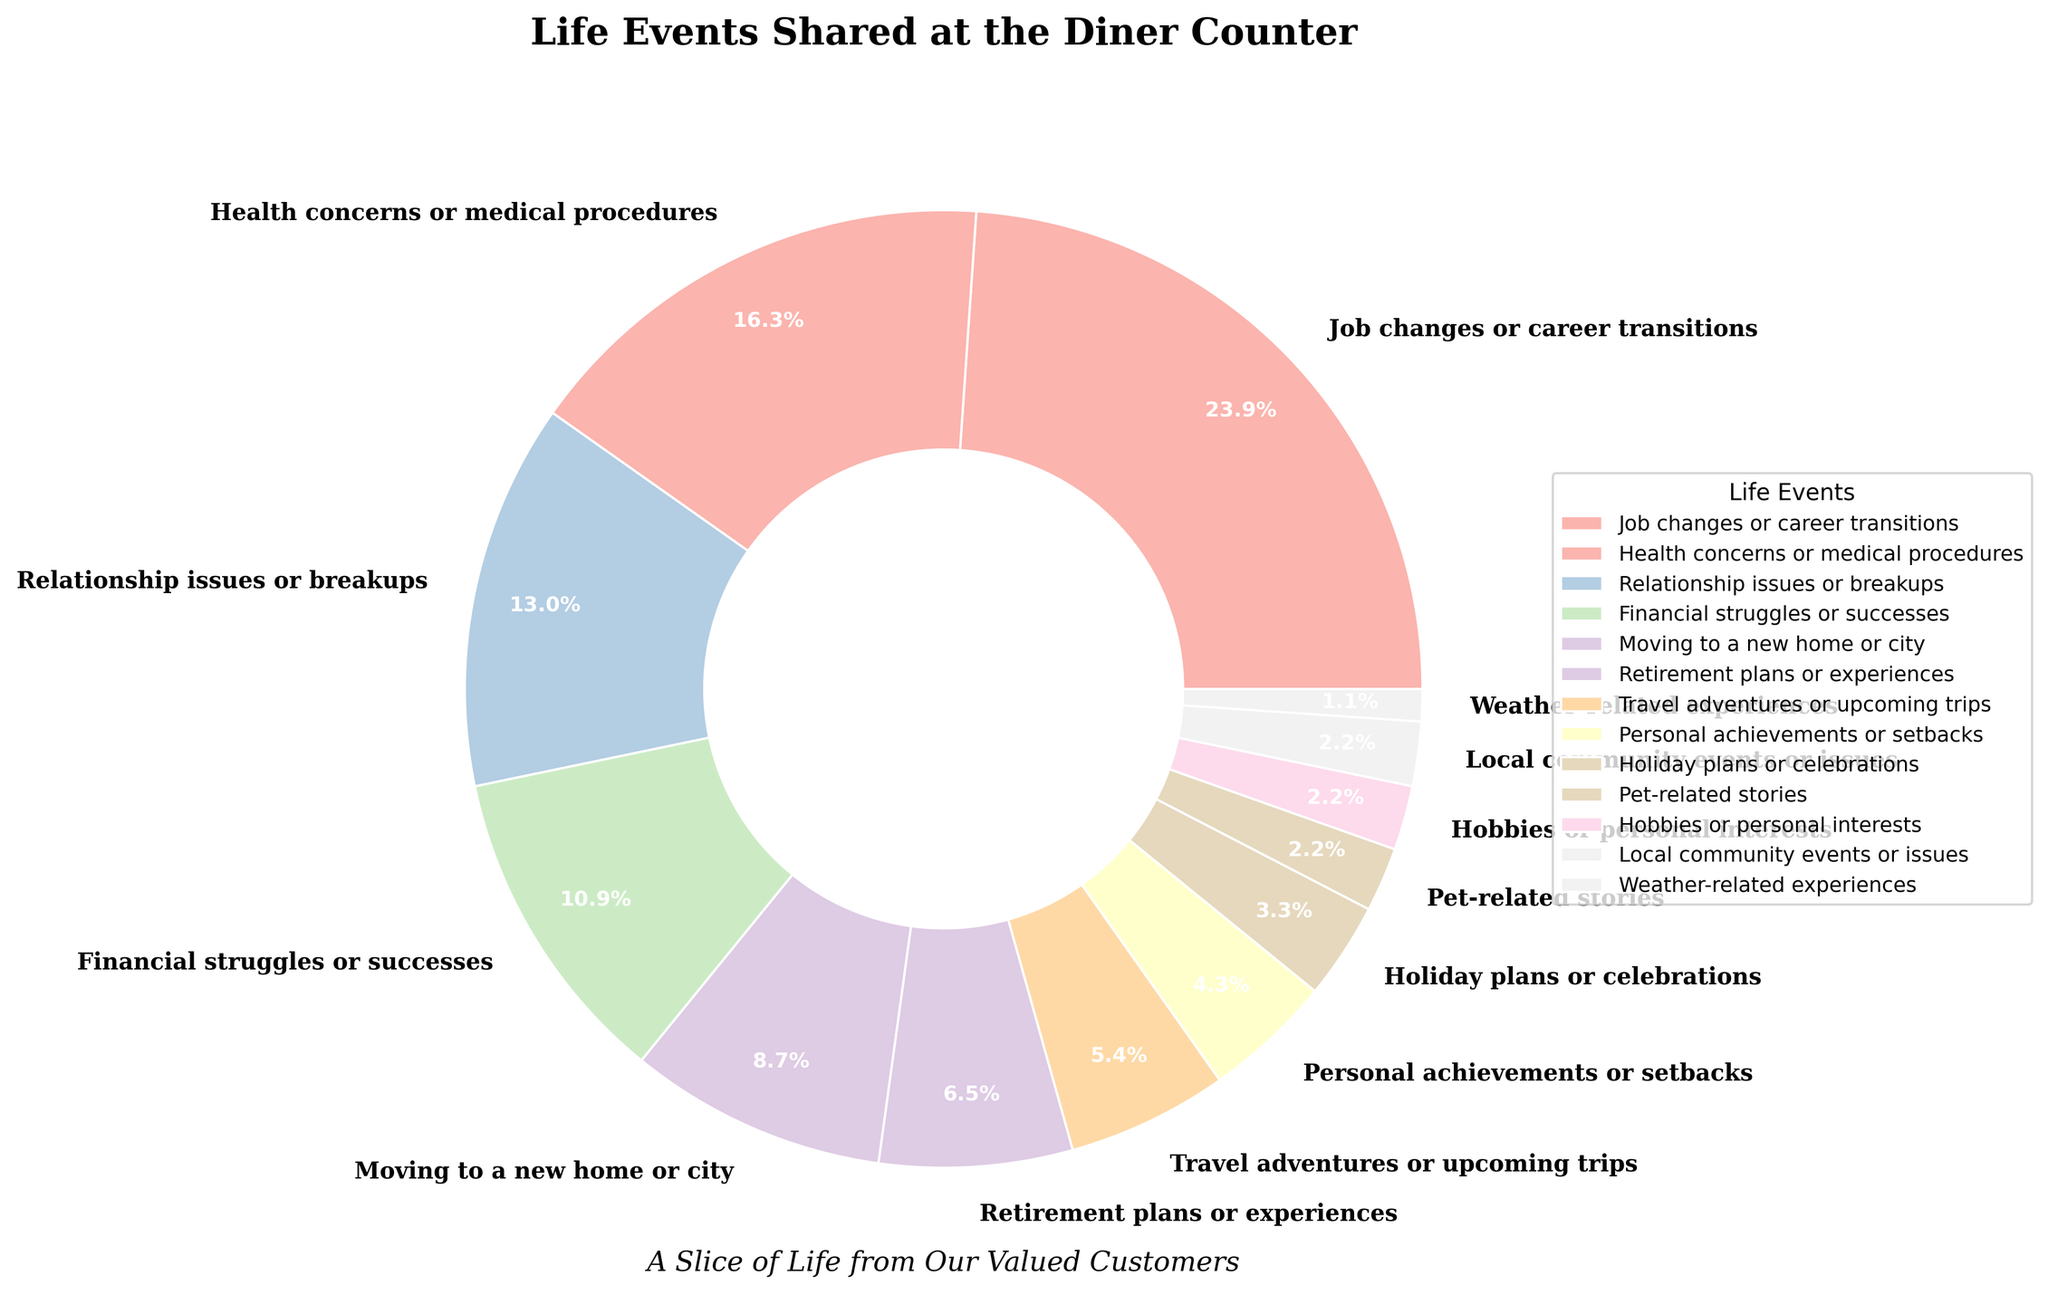Which life event is shared most frequently by customers? Refer to the largest slice in the pie chart and check its label. The largest slice is labeled "Job changes or career transitions" with a percentage of 22%.
Answer: Job changes or career transitions Which three life events are shared the least by customers? Identify the three smallest slices in the pie chart and check their labels. The slices are labeled "Weather-related experiences" (1%), "Local community events or issues" (2%), and "Pet-related stories" (2%).
Answer: Weather-related experiences, Local community events or issues, Pet-related stories What is the combined percentage of customers sharing stories related to financial struggles or successes and personal achievements or setbacks? Look at the slices labeled "Financial struggles or successes" and "Personal achievements or setbacks". Add their percentages: 10% + 4% = 14%.
Answer: 14% How does the frequency of sharing retirement plans or experiences compare to sharing travel adventures or upcoming trips? Check the slices labeled "Retirement plans or experiences" and "Travel adventures or upcoming trips". The percentages are 6% and 5%, respectively. Retirement plans or experiences are shared more frequently.
Answer: Retirement plans or experiences are more frequent What is the second most common life event shared by customers? Look for the second largest slice in the pie chart. The second largest slice is labeled "Health concerns or medical procedures" with a percentage of 15%.
Answer: Health concerns or medical procedures By what percentage does the frequency of sharing job changes exceed the frequency of sharing relationship issues? Check the slices labeled "Job changes or career transitions" (22%) and "Relationship issues or breakups" (12%). Subtract the latter from the former: 22% - 12% = 10%.
Answer: 10% How many life events categories have a percentage of 5% or less? Count the slices labeled with percentages 5% or less. These are "Travel adventures or upcoming trips" (5%), "Personal achievements or setbacks" (4%), "Holiday plans or celebrations" (3%), "Pet-related stories" (2%), "Hobbies or personal interests" (2%), "Local community events or issues" (2%), and "Weather-related experiences" (1%). There are 7 categories.
Answer: 7 Compare the combined percentage of health concerns or medical procedures and financial struggles or successes to job changes or career transitions. Which is greater? Add the percentages of "Health concerns or medical procedures" (15%) and "Financial struggles or successes" (10%): 15% + 10% = 25%. Compare 25% to the percentage of "Job changes or career transitions" (22%). The combined percentage of health concerns or medical procedures and financial struggles or successes is greater.
Answer: Combined percentage is greater 